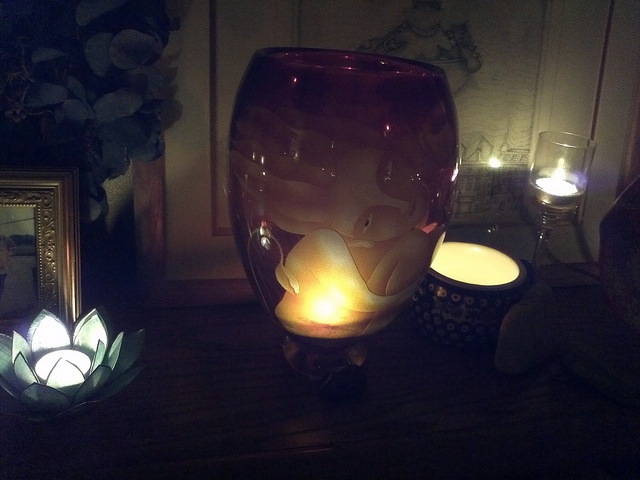Describe the objects in this image and their specific colors. I can see vase in black, brown, and gray tones, potted plant in black and gray tones, and bowl in black, khaki, and tan tones in this image. 